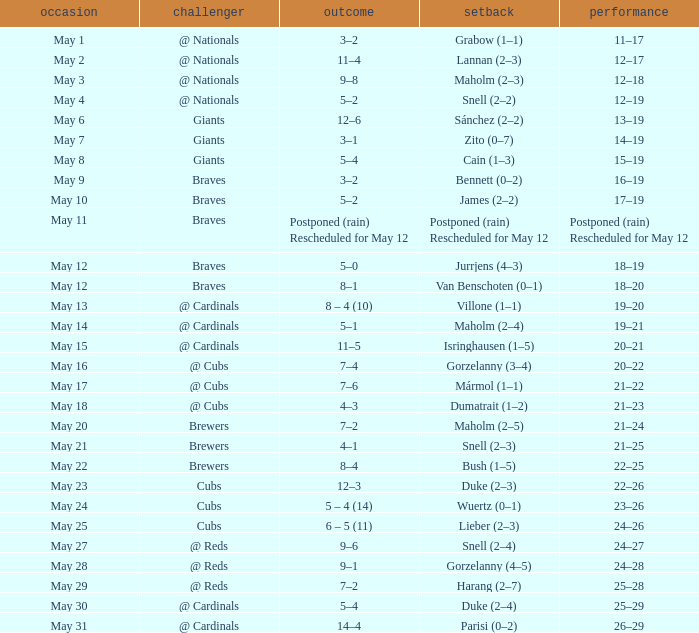What was the record of the game with a score of 12–6? 13–19. 